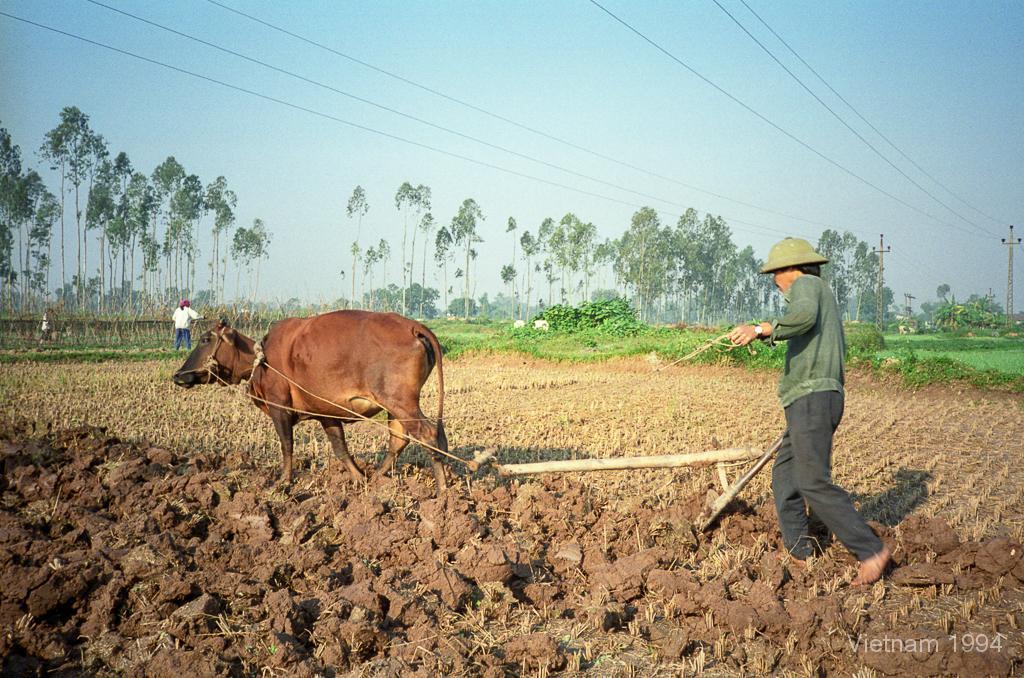In one or two sentences, can you explain what this image depicts? In this picture we see a brown cow and a string to it. To the string we see a plough and a man holding a plough, We see another man on the left and few trees and a electric pole and we see a cloudy sky and a water mark at the bottom right corner. 